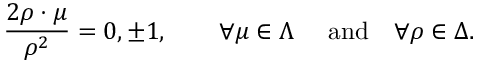Convert formula to latex. <formula><loc_0><loc_0><loc_500><loc_500>{ \frac { 2 \rho \cdot \mu } { \rho ^ { 2 } } } = 0 , \pm 1 , \quad \forall \mu \in \Lambda \quad \ a n d \quad \forall \rho \in \Delta .</formula> 